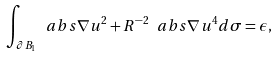<formula> <loc_0><loc_0><loc_500><loc_500>\int _ { \partial B _ { 1 } } \ a b s { \nabla u } ^ { 2 } + R ^ { - 2 } \ a b s { \nabla u } ^ { 4 } d \sigma = \epsilon ,</formula> 